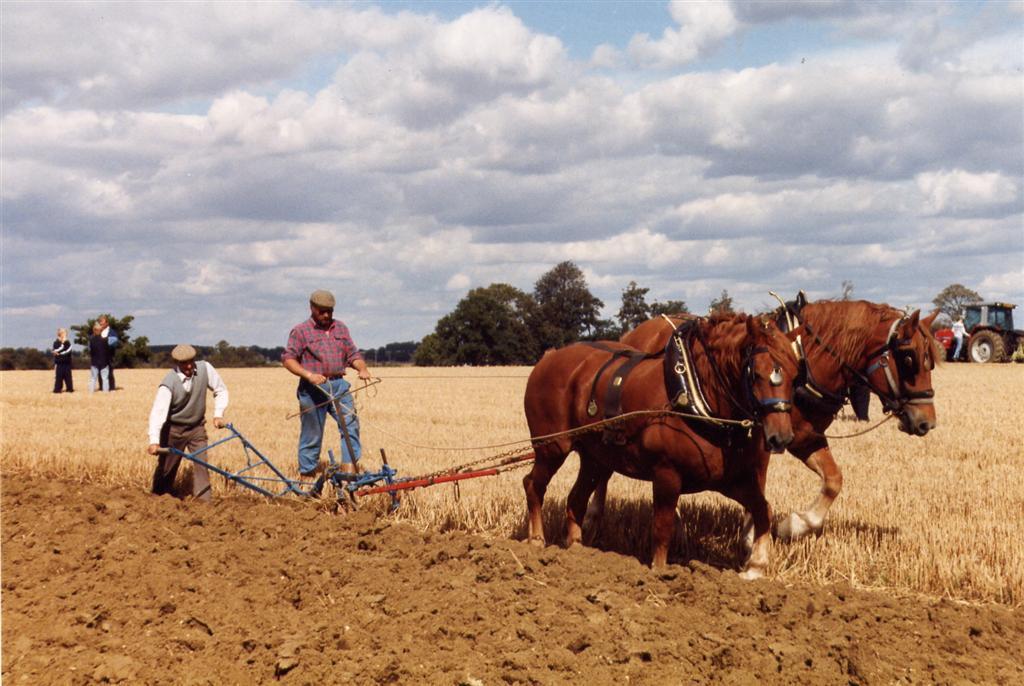Could you give a brief overview of what you see in this image? This picture is taken from outside city. In this image, on the right side, we can see two horses. On which its collar rope is holed by two men in the middle. On the right side, we can also see a tractor, we can also see a person standing in front of the tractor. On the right side, we can also see some trees. On the left side, we can see three people standing on the grass. In the middle of the image, we can see some metal rod and chains which are attached to a horse. In the background, we can see some trees and plants. At the top, we can see a sky which is a bit cloudy, at the bottom, we can see a grass and a land with some stones and sand. 